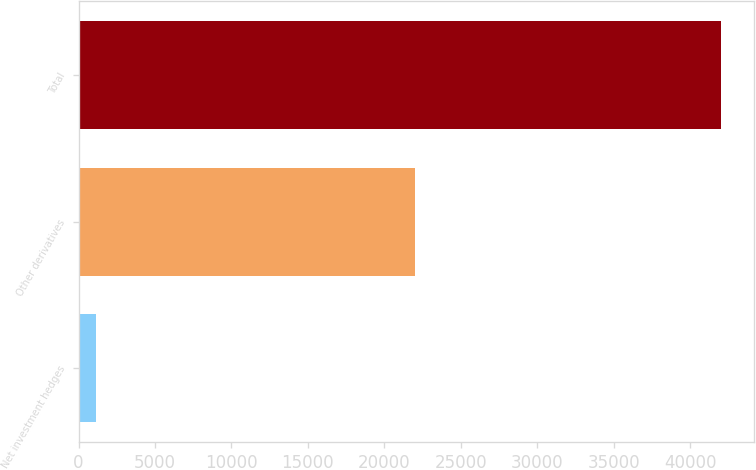<chart> <loc_0><loc_0><loc_500><loc_500><bar_chart><fcel>Net investment hedges<fcel>Other derivatives<fcel>Total<nl><fcel>1152<fcel>22013<fcel>42051<nl></chart> 